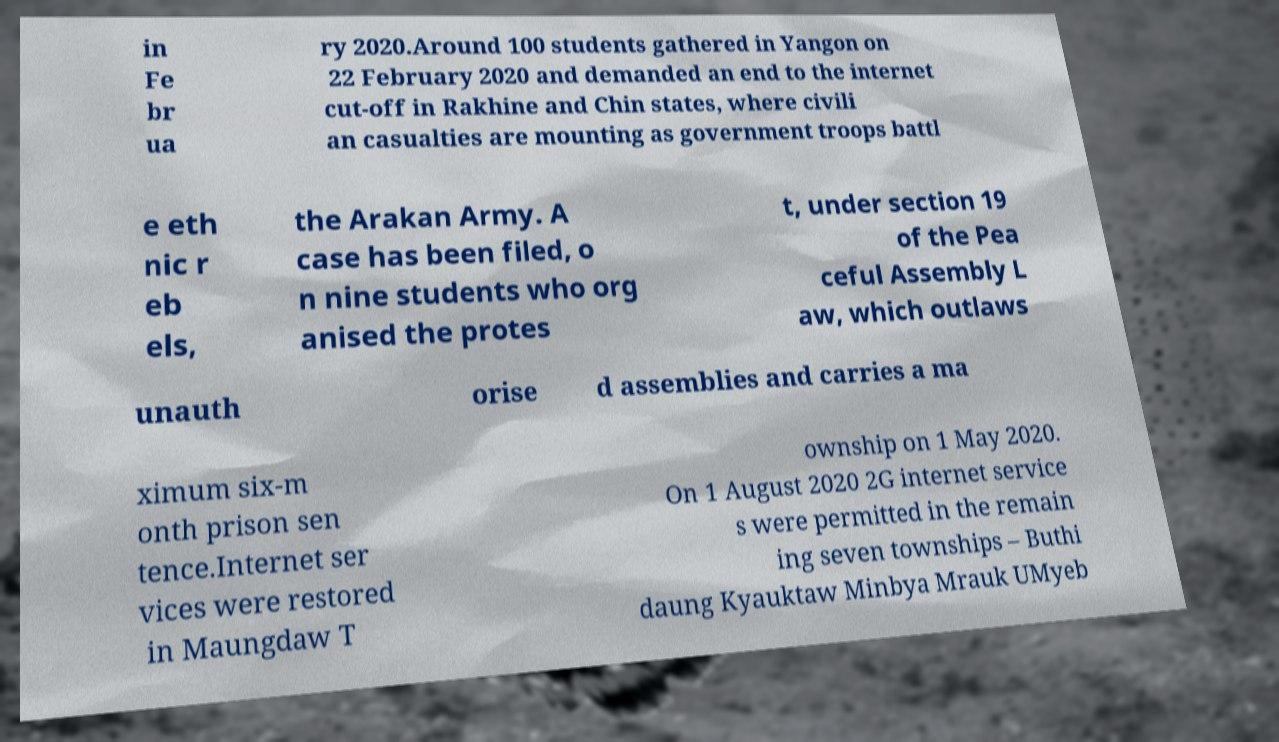There's text embedded in this image that I need extracted. Can you transcribe it verbatim? in Fe br ua ry 2020.Around 100 students gathered in Yangon on 22 February 2020 and demanded an end to the internet cut-off in Rakhine and Chin states, where civili an casualties are mounting as government troops battl e eth nic r eb els, the Arakan Army. A case has been filed, o n nine students who org anised the protes t, under section 19 of the Pea ceful Assembly L aw, which outlaws unauth orise d assemblies and carries a ma ximum six-m onth prison sen tence.Internet ser vices were restored in Maungdaw T ownship on 1 May 2020. On 1 August 2020 2G internet service s were permitted in the remain ing seven townships – Buthi daung Kyauktaw Minbya Mrauk UMyeb 